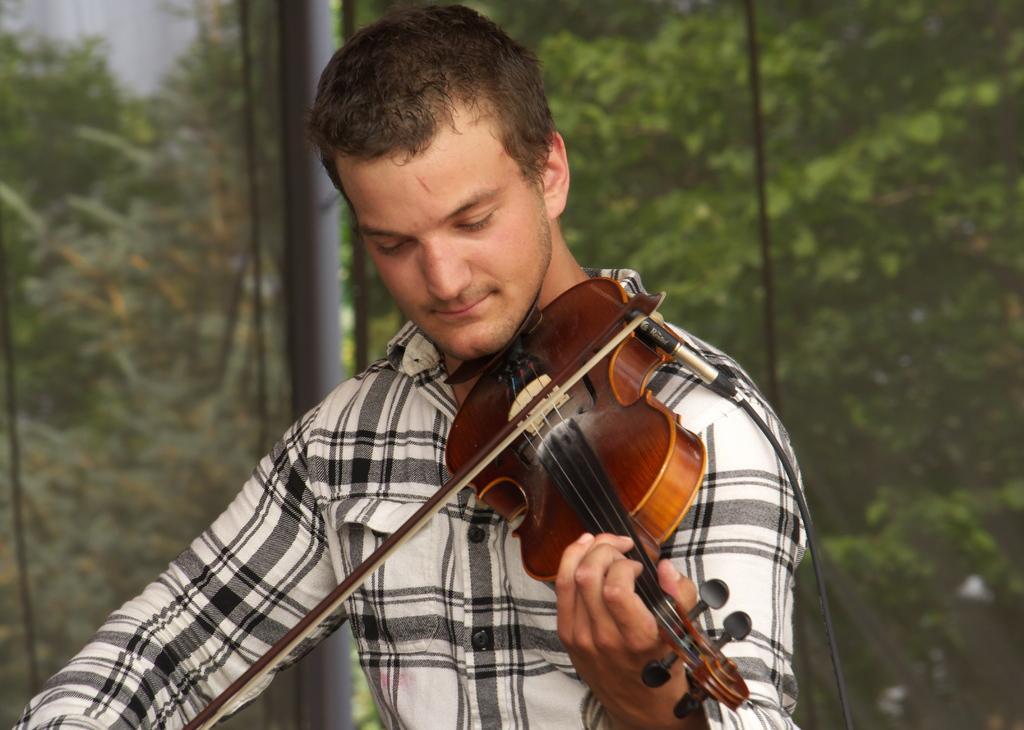Could you give a brief overview of what you see in this image? This is the picture of a man wearing white and black shirt is holding a guitar and playing it and behind him there are some trees. 